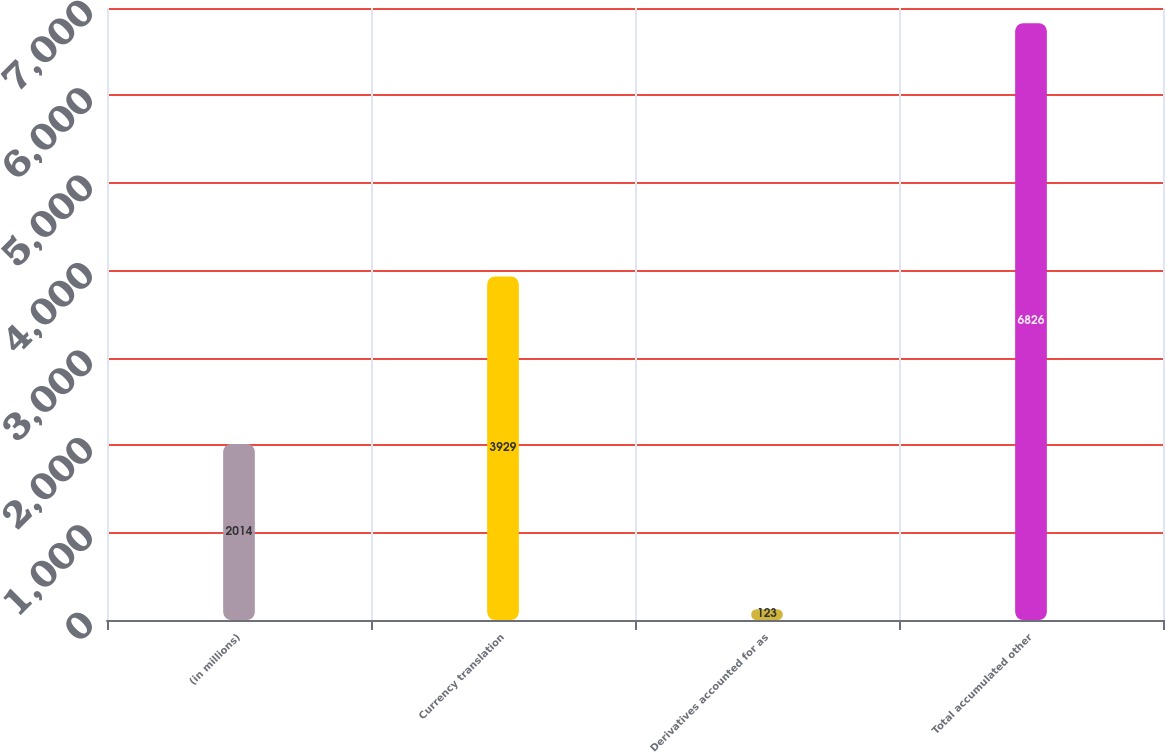<chart> <loc_0><loc_0><loc_500><loc_500><bar_chart><fcel>(in millions)<fcel>Currency translation<fcel>Derivatives accounted for as<fcel>Total accumulated other<nl><fcel>2014<fcel>3929<fcel>123<fcel>6826<nl></chart> 